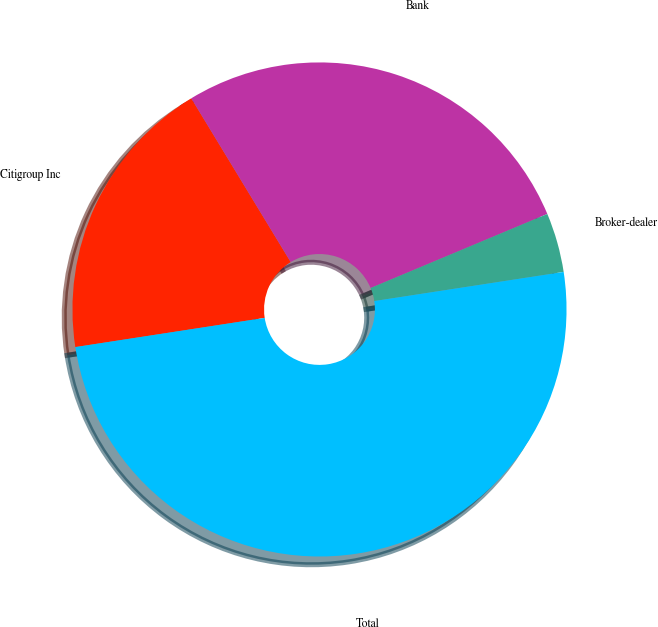Convert chart to OTSL. <chart><loc_0><loc_0><loc_500><loc_500><pie_chart><fcel>Citigroup Inc<fcel>Bank<fcel>Broker-dealer<fcel>Total<nl><fcel>18.75%<fcel>27.37%<fcel>3.89%<fcel>50.0%<nl></chart> 